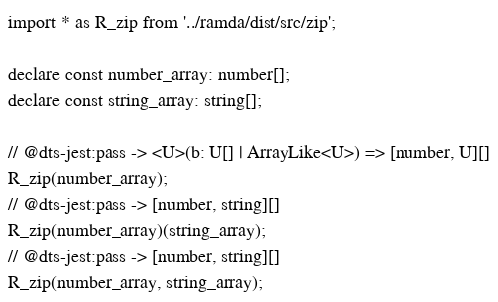Convert code to text. <code><loc_0><loc_0><loc_500><loc_500><_TypeScript_>import * as R_zip from '../ramda/dist/src/zip';

declare const number_array: number[];
declare const string_array: string[];

// @dts-jest:pass -> <U>(b: U[] | ArrayLike<U>) => [number, U][]
R_zip(number_array);
// @dts-jest:pass -> [number, string][]
R_zip(number_array)(string_array);
// @dts-jest:pass -> [number, string][]
R_zip(number_array, string_array);
</code> 